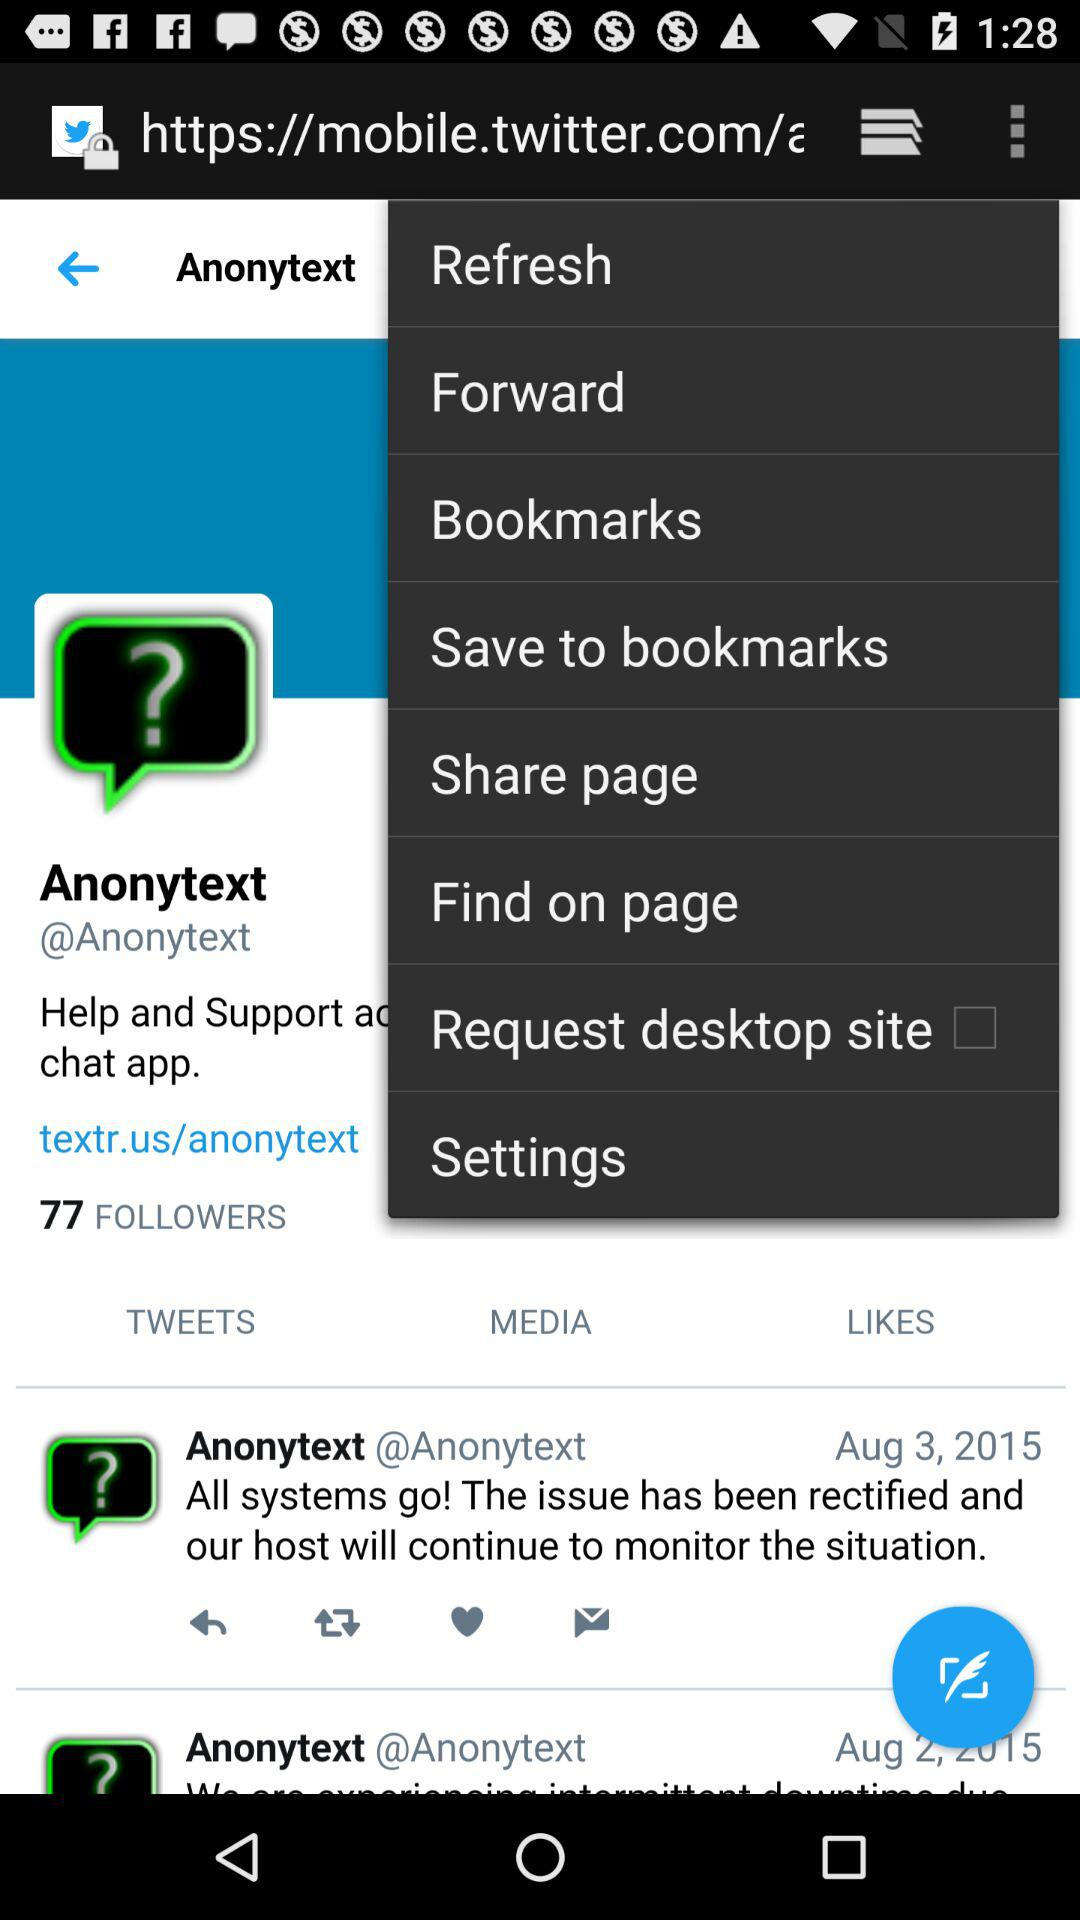How many followers does Anonytext have? Anonytext has 77 followers. 